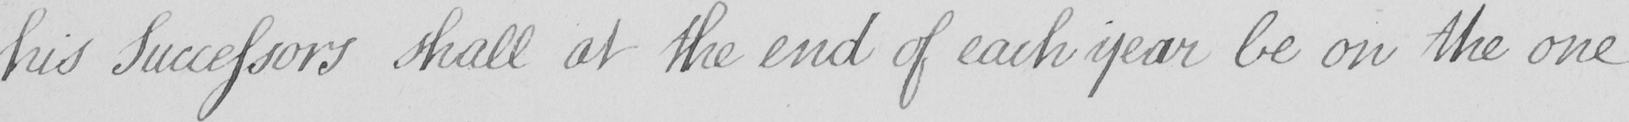What does this handwritten line say? his Successors shall at the end of each year be on the one 